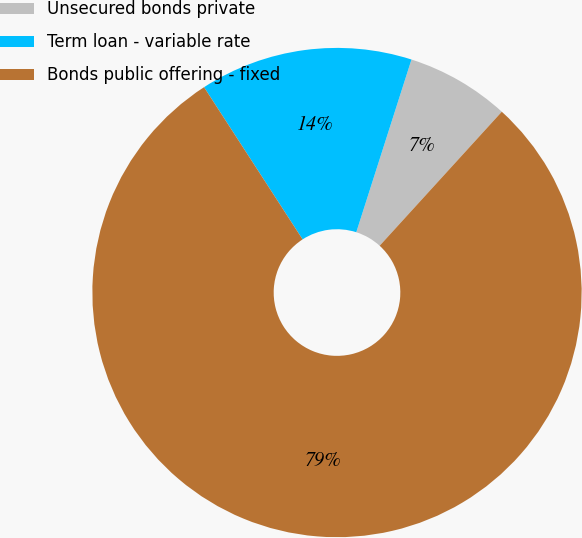Convert chart. <chart><loc_0><loc_0><loc_500><loc_500><pie_chart><fcel>Unsecured bonds private<fcel>Term loan - variable rate<fcel>Bonds public offering - fixed<nl><fcel>6.84%<fcel>14.07%<fcel>79.1%<nl></chart> 